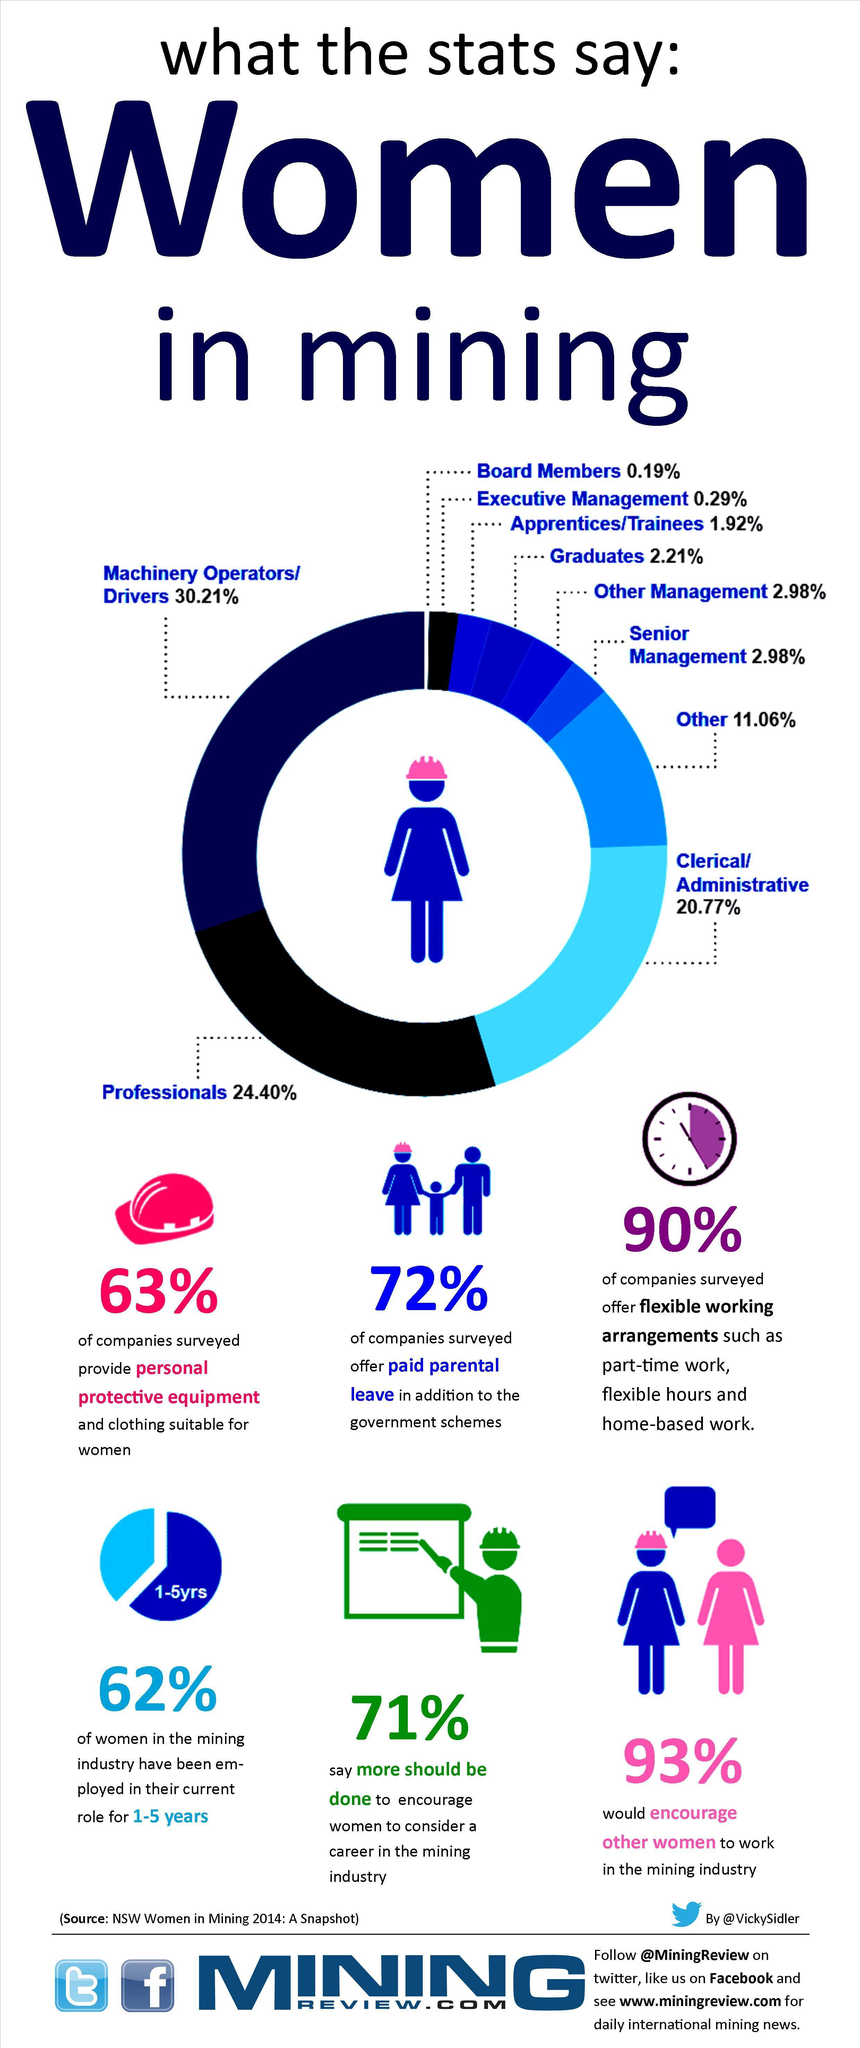What percent of mining companies offered paid parental leave?
Answer the question with a short phrase. 72% How many of the women have been in mining industry for 1-5 years? 62% what percent say more effort is needed to encourage ladies choose a career in mining industry? 71% What percent of the companies offered flexible work options? 90% How many of the companies provided PPE and clothing suitable for women? 63% What percent of women encourage other women to work in mining industry? 93% 